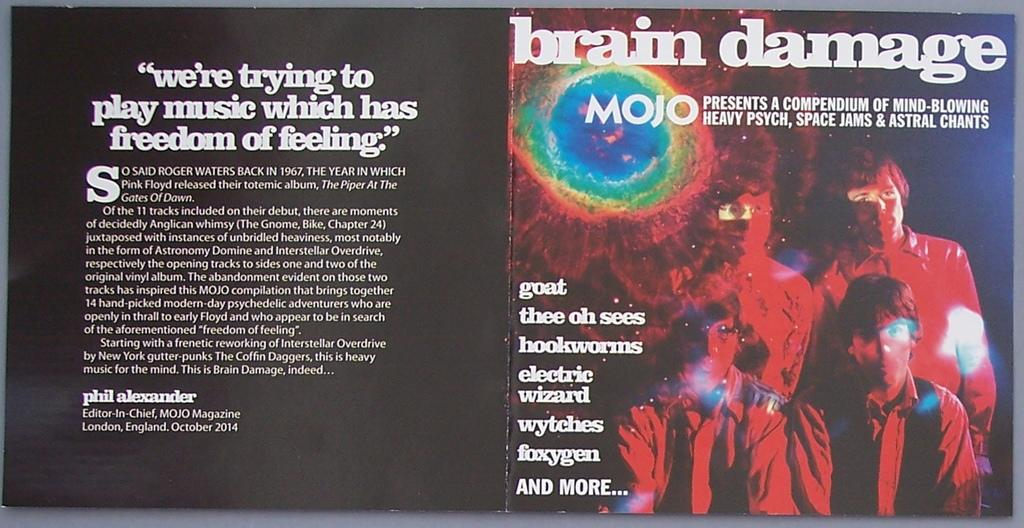What is the main object in the image? There is a board in the image. What is written or depicted on the board? There is text on the board, and there are images of people on the board. Can you see a horse running through the wilderness in the background of the image? There is no horse or wilderness present in the image; it only features a board with text and images of people. 